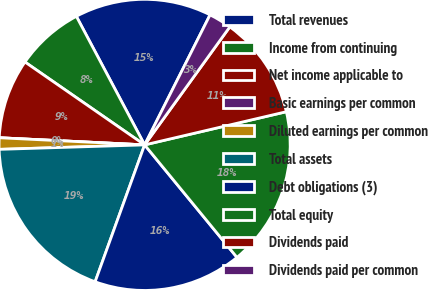<chart> <loc_0><loc_0><loc_500><loc_500><pie_chart><fcel>Total revenues<fcel>Income from continuing<fcel>Net income applicable to<fcel>Basic earnings per common<fcel>Diluted earnings per common<fcel>Total assets<fcel>Debt obligations (3)<fcel>Total equity<fcel>Dividends paid<fcel>Dividends paid per common<nl><fcel>15.19%<fcel>7.59%<fcel>8.86%<fcel>0.0%<fcel>1.27%<fcel>18.99%<fcel>16.46%<fcel>17.72%<fcel>11.39%<fcel>2.53%<nl></chart> 